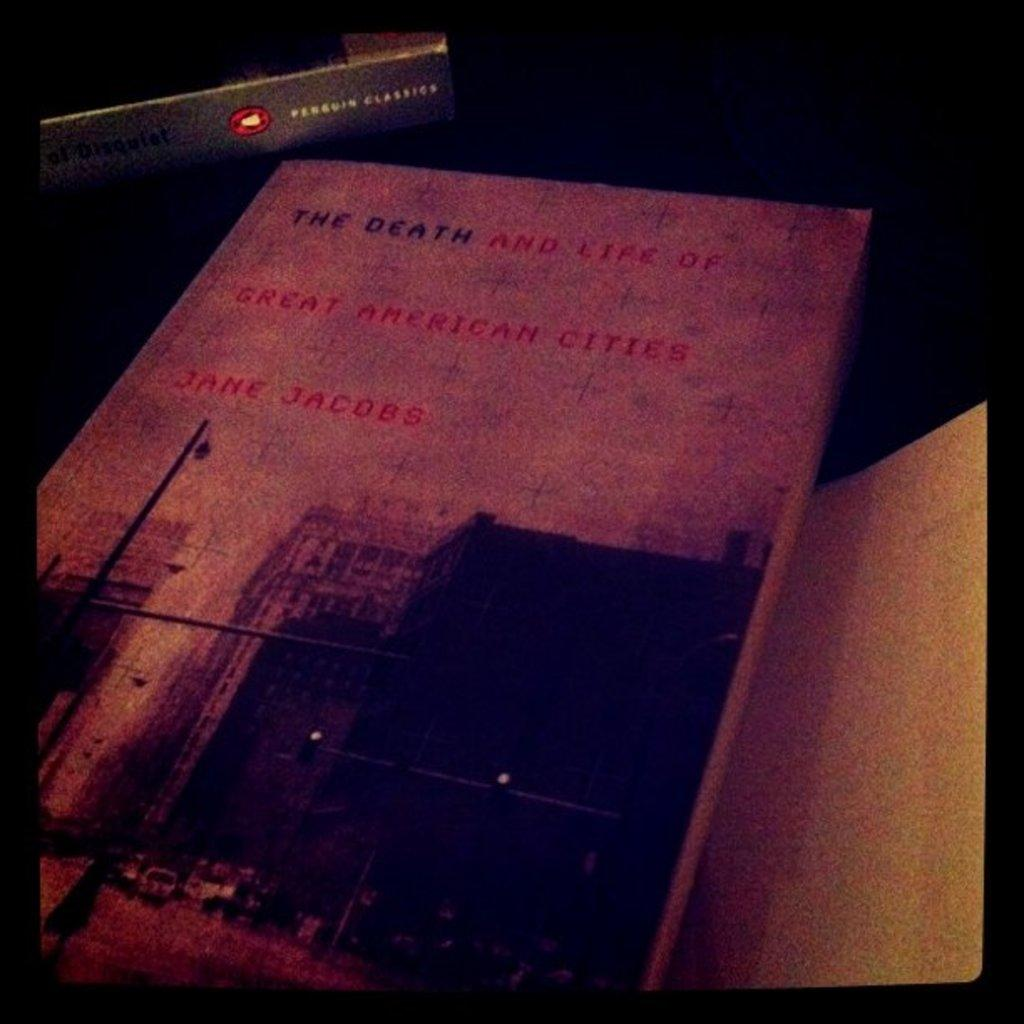Provide a one-sentence caption for the provided image. An old book by Jane Jacobs called The Death and Life of Great American Cities. 